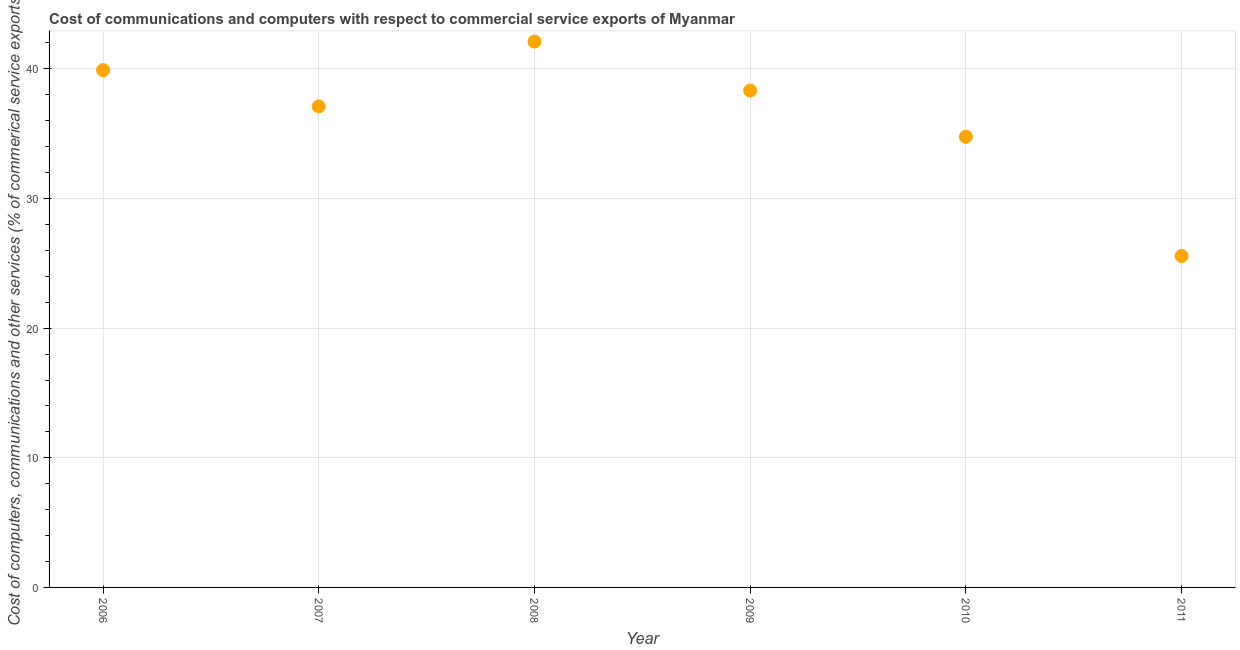What is the  computer and other services in 2007?
Ensure brevity in your answer.  37.11. Across all years, what is the maximum cost of communications?
Your response must be concise. 42.11. Across all years, what is the minimum  computer and other services?
Provide a succinct answer. 25.56. In which year was the  computer and other services minimum?
Offer a very short reply. 2011. What is the sum of the cost of communications?
Make the answer very short. 217.78. What is the difference between the  computer and other services in 2006 and 2011?
Your answer should be very brief. 14.34. What is the average  computer and other services per year?
Ensure brevity in your answer.  36.3. What is the median  computer and other services?
Offer a terse response. 37.72. In how many years, is the  computer and other services greater than 30 %?
Provide a short and direct response. 5. Do a majority of the years between 2009 and 2011 (inclusive) have cost of communications greater than 4 %?
Ensure brevity in your answer.  Yes. What is the ratio of the cost of communications in 2007 to that in 2011?
Make the answer very short. 1.45. Is the difference between the cost of communications in 2006 and 2011 greater than the difference between any two years?
Provide a short and direct response. No. What is the difference between the highest and the second highest cost of communications?
Your answer should be very brief. 2.2. Is the sum of the cost of communications in 2008 and 2009 greater than the maximum cost of communications across all years?
Offer a very short reply. Yes. What is the difference between the highest and the lowest cost of communications?
Your answer should be very brief. 16.55. In how many years, is the cost of communications greater than the average cost of communications taken over all years?
Keep it short and to the point. 4. Does the cost of communications monotonically increase over the years?
Offer a terse response. No. How many dotlines are there?
Your answer should be very brief. 1. What is the difference between two consecutive major ticks on the Y-axis?
Offer a very short reply. 10. Are the values on the major ticks of Y-axis written in scientific E-notation?
Your response must be concise. No. Does the graph contain any zero values?
Offer a very short reply. No. What is the title of the graph?
Offer a terse response. Cost of communications and computers with respect to commercial service exports of Myanmar. What is the label or title of the Y-axis?
Provide a succinct answer. Cost of computers, communications and other services (% of commerical service exports). What is the Cost of computers, communications and other services (% of commerical service exports) in 2006?
Give a very brief answer. 39.91. What is the Cost of computers, communications and other services (% of commerical service exports) in 2007?
Keep it short and to the point. 37.11. What is the Cost of computers, communications and other services (% of commerical service exports) in 2008?
Your answer should be compact. 42.11. What is the Cost of computers, communications and other services (% of commerical service exports) in 2009?
Give a very brief answer. 38.33. What is the Cost of computers, communications and other services (% of commerical service exports) in 2010?
Ensure brevity in your answer.  34.77. What is the Cost of computers, communications and other services (% of commerical service exports) in 2011?
Your response must be concise. 25.56. What is the difference between the Cost of computers, communications and other services (% of commerical service exports) in 2006 and 2007?
Offer a terse response. 2.8. What is the difference between the Cost of computers, communications and other services (% of commerical service exports) in 2006 and 2008?
Ensure brevity in your answer.  -2.2. What is the difference between the Cost of computers, communications and other services (% of commerical service exports) in 2006 and 2009?
Offer a terse response. 1.58. What is the difference between the Cost of computers, communications and other services (% of commerical service exports) in 2006 and 2010?
Your answer should be compact. 5.14. What is the difference between the Cost of computers, communications and other services (% of commerical service exports) in 2006 and 2011?
Keep it short and to the point. 14.34. What is the difference between the Cost of computers, communications and other services (% of commerical service exports) in 2007 and 2008?
Ensure brevity in your answer.  -5.01. What is the difference between the Cost of computers, communications and other services (% of commerical service exports) in 2007 and 2009?
Offer a terse response. -1.23. What is the difference between the Cost of computers, communications and other services (% of commerical service exports) in 2007 and 2010?
Keep it short and to the point. 2.34. What is the difference between the Cost of computers, communications and other services (% of commerical service exports) in 2007 and 2011?
Your response must be concise. 11.54. What is the difference between the Cost of computers, communications and other services (% of commerical service exports) in 2008 and 2009?
Keep it short and to the point. 3.78. What is the difference between the Cost of computers, communications and other services (% of commerical service exports) in 2008 and 2010?
Ensure brevity in your answer.  7.34. What is the difference between the Cost of computers, communications and other services (% of commerical service exports) in 2008 and 2011?
Offer a terse response. 16.55. What is the difference between the Cost of computers, communications and other services (% of commerical service exports) in 2009 and 2010?
Your answer should be compact. 3.56. What is the difference between the Cost of computers, communications and other services (% of commerical service exports) in 2009 and 2011?
Provide a succinct answer. 12.77. What is the difference between the Cost of computers, communications and other services (% of commerical service exports) in 2010 and 2011?
Keep it short and to the point. 9.2. What is the ratio of the Cost of computers, communications and other services (% of commerical service exports) in 2006 to that in 2007?
Provide a succinct answer. 1.08. What is the ratio of the Cost of computers, communications and other services (% of commerical service exports) in 2006 to that in 2008?
Keep it short and to the point. 0.95. What is the ratio of the Cost of computers, communications and other services (% of commerical service exports) in 2006 to that in 2009?
Offer a terse response. 1.04. What is the ratio of the Cost of computers, communications and other services (% of commerical service exports) in 2006 to that in 2010?
Ensure brevity in your answer.  1.15. What is the ratio of the Cost of computers, communications and other services (% of commerical service exports) in 2006 to that in 2011?
Your answer should be very brief. 1.56. What is the ratio of the Cost of computers, communications and other services (% of commerical service exports) in 2007 to that in 2008?
Provide a succinct answer. 0.88. What is the ratio of the Cost of computers, communications and other services (% of commerical service exports) in 2007 to that in 2010?
Provide a succinct answer. 1.07. What is the ratio of the Cost of computers, communications and other services (% of commerical service exports) in 2007 to that in 2011?
Make the answer very short. 1.45. What is the ratio of the Cost of computers, communications and other services (% of commerical service exports) in 2008 to that in 2009?
Provide a succinct answer. 1.1. What is the ratio of the Cost of computers, communications and other services (% of commerical service exports) in 2008 to that in 2010?
Keep it short and to the point. 1.21. What is the ratio of the Cost of computers, communications and other services (% of commerical service exports) in 2008 to that in 2011?
Your answer should be compact. 1.65. What is the ratio of the Cost of computers, communications and other services (% of commerical service exports) in 2009 to that in 2010?
Ensure brevity in your answer.  1.1. What is the ratio of the Cost of computers, communications and other services (% of commerical service exports) in 2009 to that in 2011?
Your response must be concise. 1.5. What is the ratio of the Cost of computers, communications and other services (% of commerical service exports) in 2010 to that in 2011?
Your response must be concise. 1.36. 